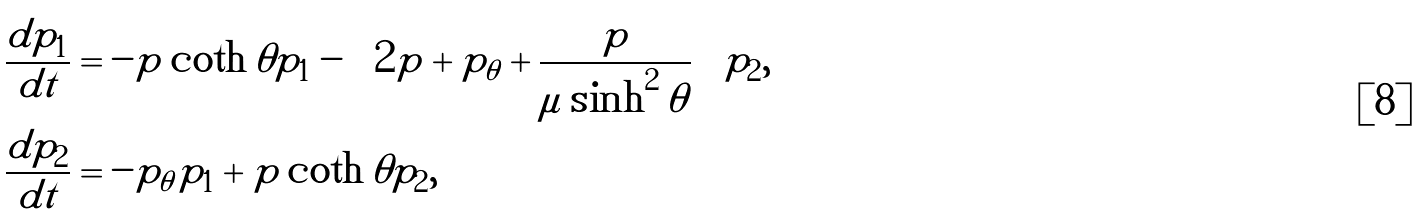Convert formula to latex. <formula><loc_0><loc_0><loc_500><loc_500>\frac { d p _ { 1 } } { d t } & = - p \coth \theta p _ { 1 } - \left ( 2 p + p _ { \theta } + \frac { p } { \mu \sinh ^ { 2 } \theta } \right ) p _ { 2 } , \\ \frac { d p _ { 2 } } { d t } & = - p _ { \theta } p _ { 1 } + p \coth \theta p _ { 2 } ,</formula> 